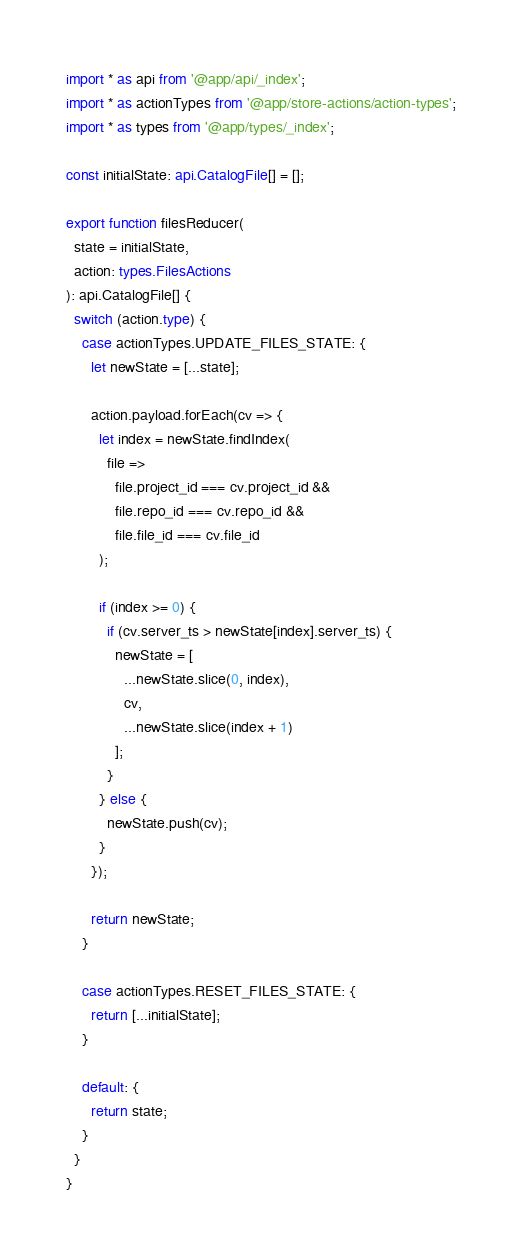<code> <loc_0><loc_0><loc_500><loc_500><_TypeScript_>import * as api from '@app/api/_index';
import * as actionTypes from '@app/store-actions/action-types';
import * as types from '@app/types/_index';

const initialState: api.CatalogFile[] = [];

export function filesReducer(
  state = initialState,
  action: types.FilesActions
): api.CatalogFile[] {
  switch (action.type) {
    case actionTypes.UPDATE_FILES_STATE: {
      let newState = [...state];

      action.payload.forEach(cv => {
        let index = newState.findIndex(
          file =>
            file.project_id === cv.project_id &&
            file.repo_id === cv.repo_id &&
            file.file_id === cv.file_id
        );

        if (index >= 0) {
          if (cv.server_ts > newState[index].server_ts) {
            newState = [
              ...newState.slice(0, index),
              cv,
              ...newState.slice(index + 1)
            ];
          }
        } else {
          newState.push(cv);
        }
      });

      return newState;
    }

    case actionTypes.RESET_FILES_STATE: {
      return [...initialState];
    }

    default: {
      return state;
    }
  }
}
</code> 